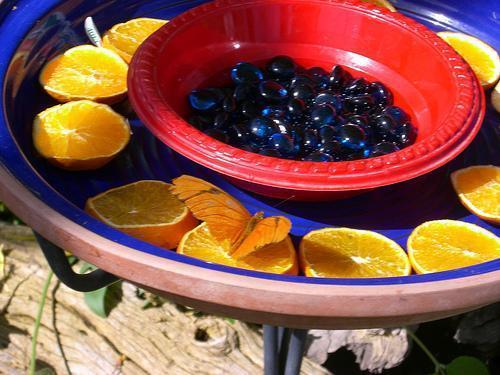How many pieces of orange are in the photo?
Give a very brief answer. 11. 